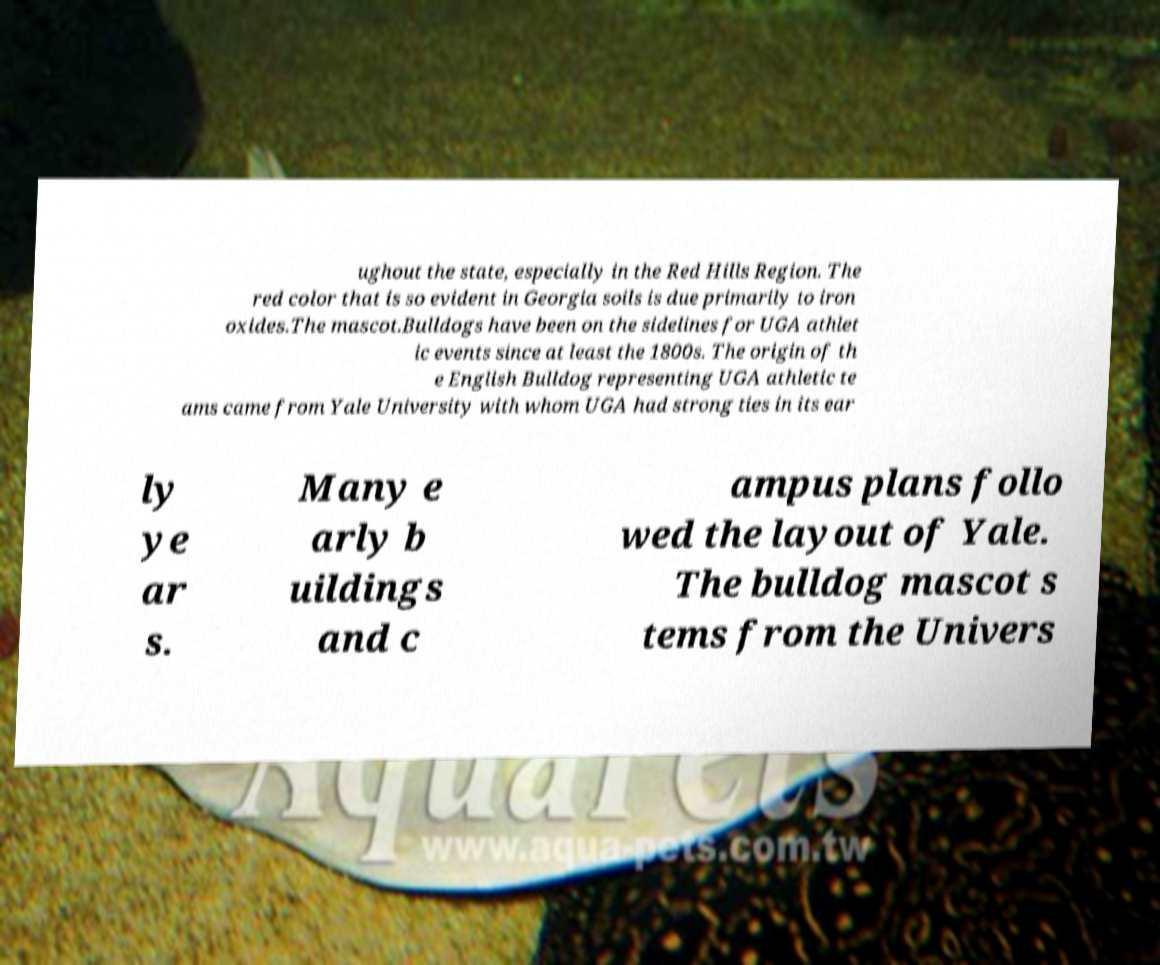I need the written content from this picture converted into text. Can you do that? ughout the state, especially in the Red Hills Region. The red color that is so evident in Georgia soils is due primarily to iron oxides.The mascot.Bulldogs have been on the sidelines for UGA athlet ic events since at least the 1800s. The origin of th e English Bulldog representing UGA athletic te ams came from Yale University with whom UGA had strong ties in its ear ly ye ar s. Many e arly b uildings and c ampus plans follo wed the layout of Yale. The bulldog mascot s tems from the Univers 